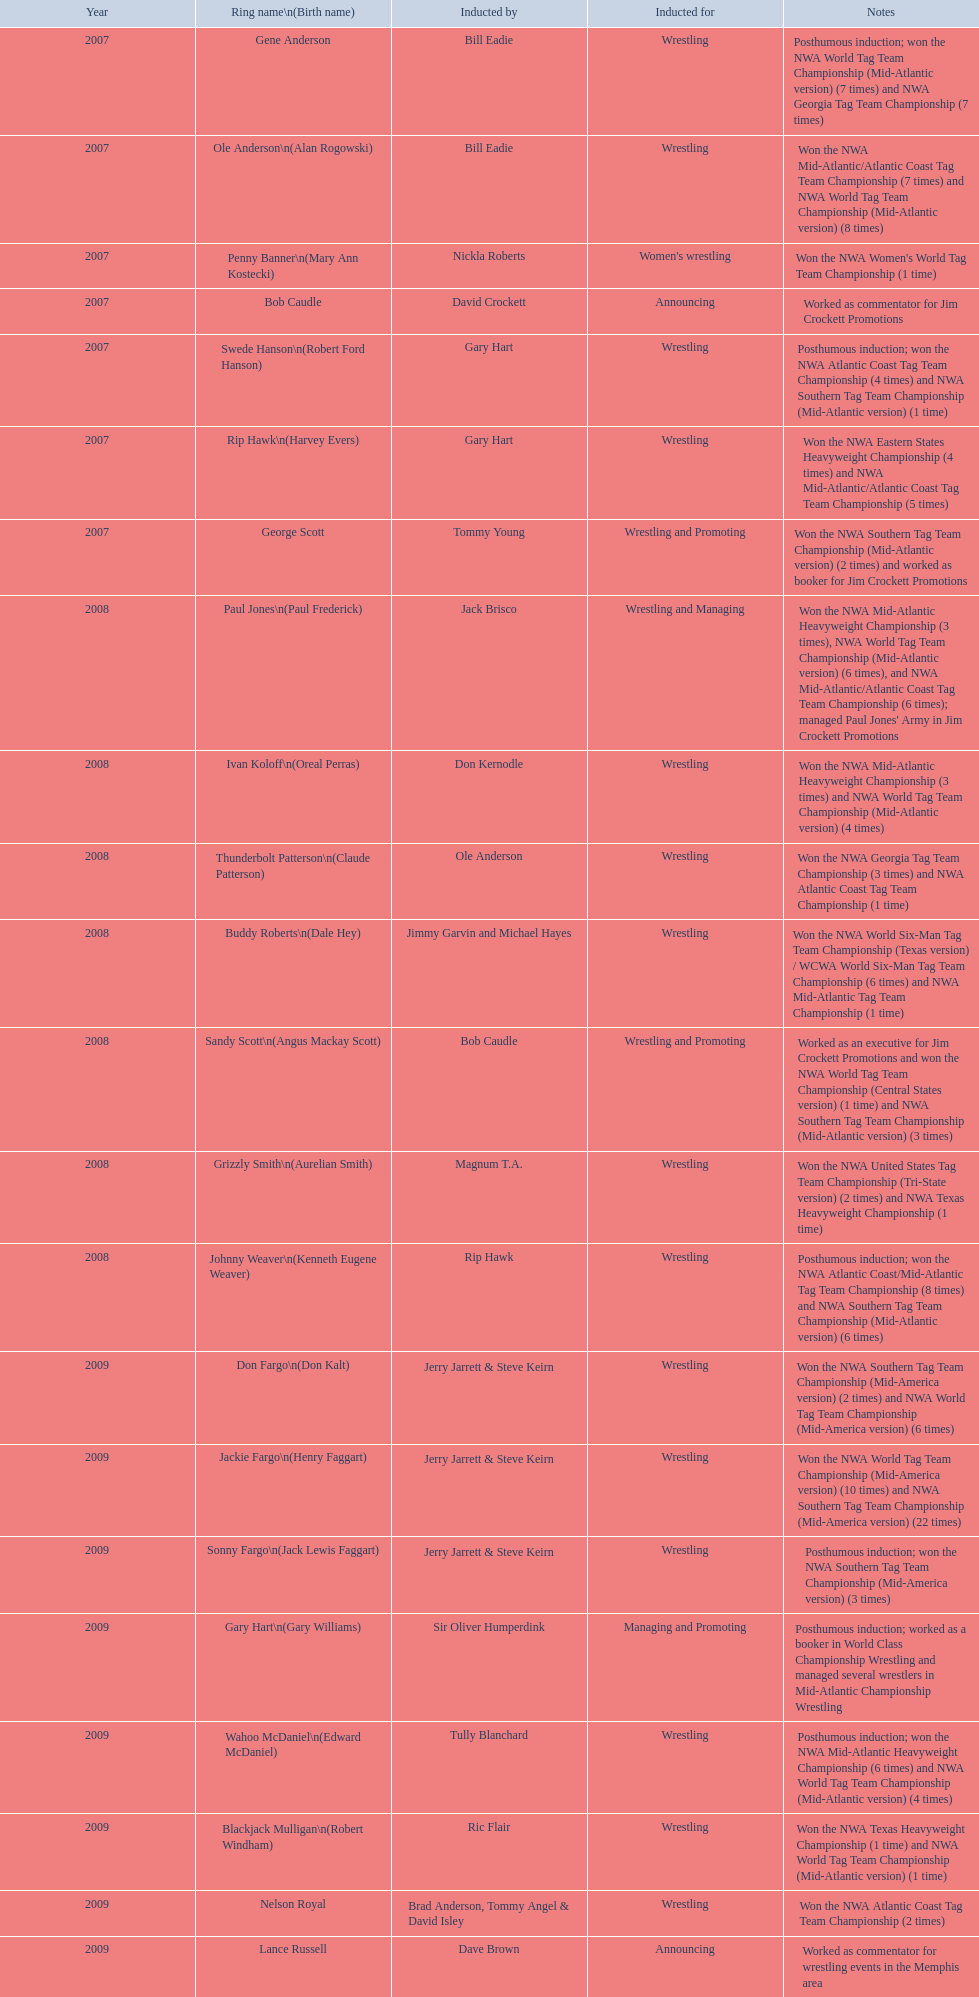In what year did the induction take place? 2007. Which inductee was deceased at the time? Gene Anderson. 